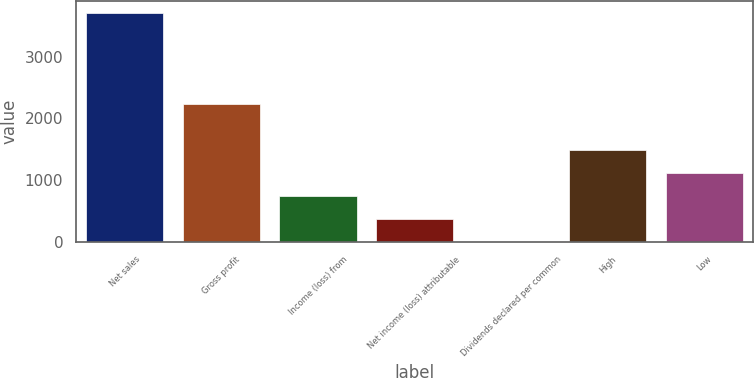Convert chart to OTSL. <chart><loc_0><loc_0><loc_500><loc_500><bar_chart><fcel>Net sales<fcel>Gross profit<fcel>Income (loss) from<fcel>Net income (loss) attributable<fcel>Dividends declared per common<fcel>High<fcel>Low<nl><fcel>3715.8<fcel>2229.61<fcel>743.37<fcel>371.81<fcel>0.25<fcel>1486.49<fcel>1114.93<nl></chart> 